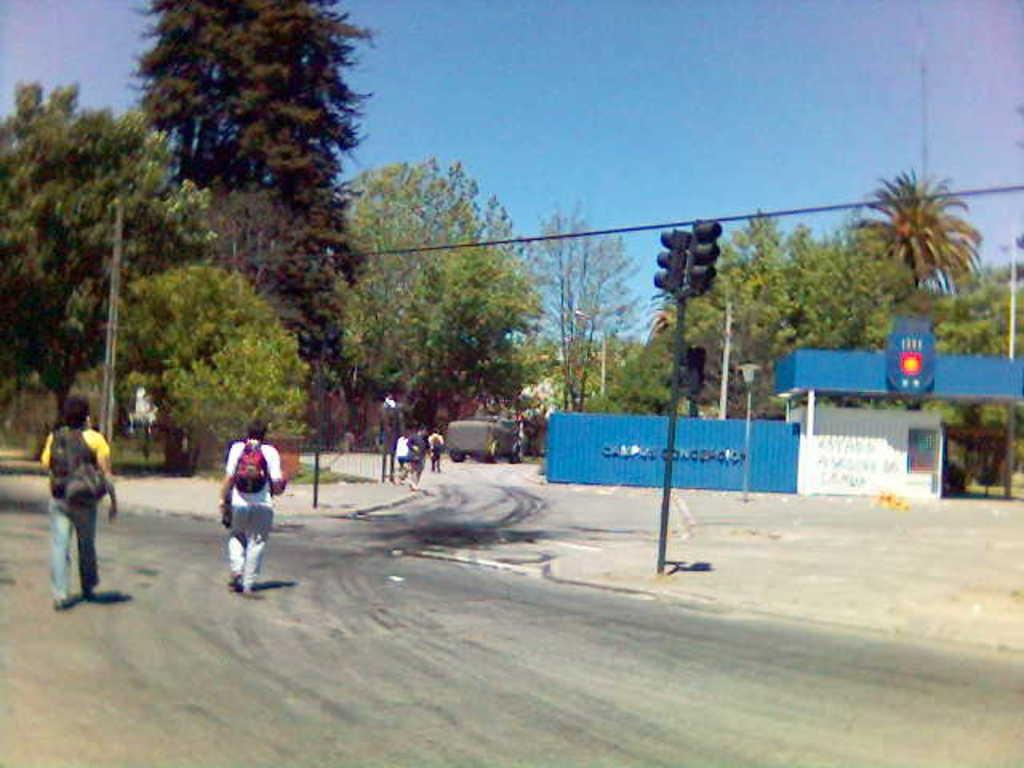What are the people in the image doing? The people in the image are walking on the road. What else can be seen on the road? There is a vehicle on the road. What structure is present in the image? There is a shed in the image. What type of vegetation is visible in the image? There are trees in the image. What traffic control device is present in the image? There is a traffic signal in the image. What else can be seen in the image that is related to infrastructure? There is a pole with wires in the image. What can be seen in the background of the image? The sky is visible in the background of the image. What type of fruit is being sold at the shed in the image? There is no fruit being sold at the shed in the image; it is a structure with no visible items for sale. How long does it take for the traffic signal to change in the image? The provided facts do not mention the duration of the traffic signal's cycle, so it cannot be determined from the image. 